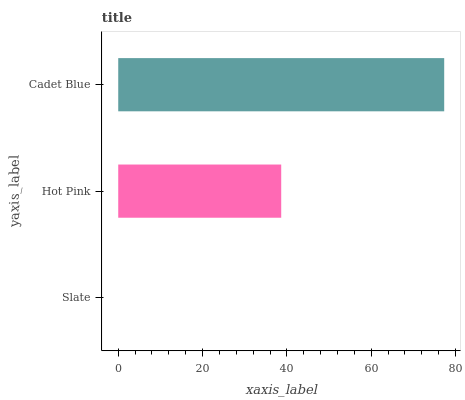Is Slate the minimum?
Answer yes or no. Yes. Is Cadet Blue the maximum?
Answer yes or no. Yes. Is Hot Pink the minimum?
Answer yes or no. No. Is Hot Pink the maximum?
Answer yes or no. No. Is Hot Pink greater than Slate?
Answer yes or no. Yes. Is Slate less than Hot Pink?
Answer yes or no. Yes. Is Slate greater than Hot Pink?
Answer yes or no. No. Is Hot Pink less than Slate?
Answer yes or no. No. Is Hot Pink the high median?
Answer yes or no. Yes. Is Hot Pink the low median?
Answer yes or no. Yes. Is Cadet Blue the high median?
Answer yes or no. No. Is Slate the low median?
Answer yes or no. No. 